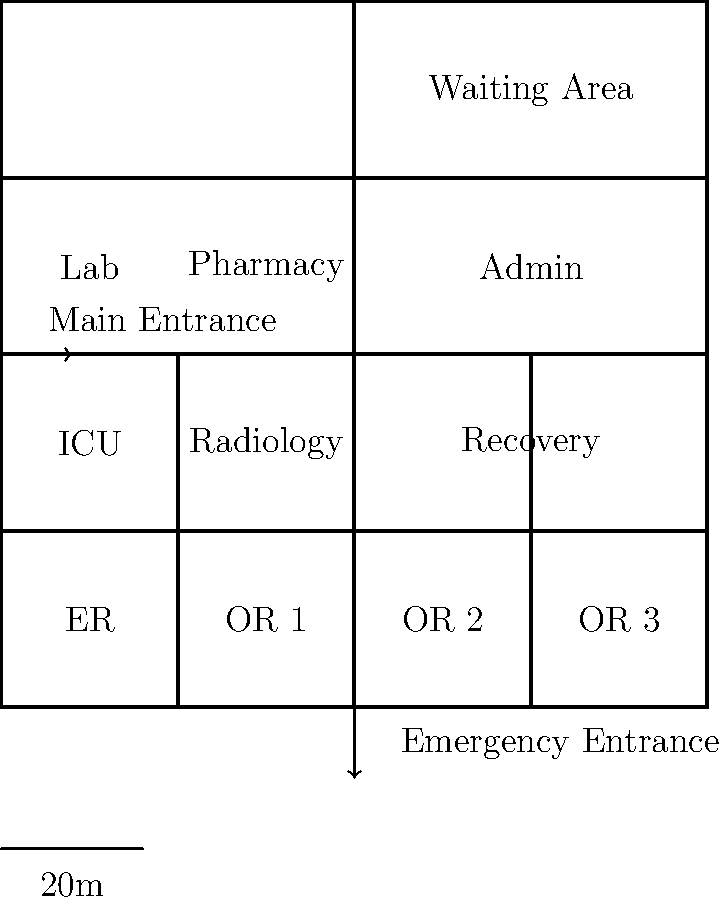As the pioneer of innovative patient care, you're tasked with optimizing the hospital's layout for efficient emergency response. Given the floor plan, what is the minimum number of turns required for a patient to be transferred from the Emergency Room (ER) to Operating Room 2 (OR 2), assuming all doorways are in the center of each wall section? Let's approach this step-by-step:

1. Identify the starting point (ER) and the destination (OR 2).
   - ER is located in the bottom-left quadrant of the floor plan.
   - OR 2 is located in the top-right quadrant of the floor plan.

2. Trace the most direct path from ER to OR 2:
   a. Exit ER through its right wall into the corridor.
   b. Turn right (1st turn) to move towards the center of the hospital.
   c. At the central intersection, turn left (2nd turn) to move towards the upper half of the hospital.
   d. After passing the Recovery room, turn right (3rd turn) into OR 2.

3. Count the number of turns:
   - The path requires 3 turns in total.

4. Verify if there's a more efficient route:
   - There is no route with fewer turns due to the layout of the walls and corridors.

Therefore, the minimum number of turns required to transfer a patient from ER to OR 2 is 3.
Answer: 3 turns 